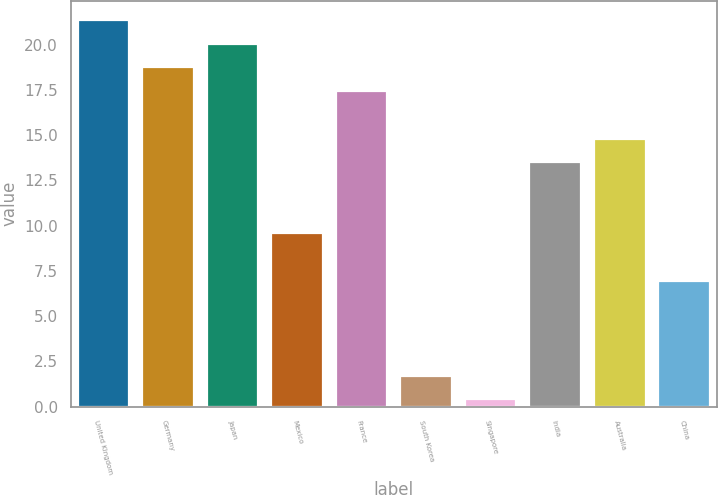Convert chart to OTSL. <chart><loc_0><loc_0><loc_500><loc_500><bar_chart><fcel>United Kingdom<fcel>Germany<fcel>Japan<fcel>Mexico<fcel>France<fcel>South Korea<fcel>Singapore<fcel>India<fcel>Australia<fcel>China<nl><fcel>21.36<fcel>18.74<fcel>20.05<fcel>9.57<fcel>17.43<fcel>1.71<fcel>0.4<fcel>13.5<fcel>14.81<fcel>6.95<nl></chart> 